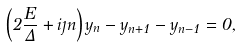<formula> <loc_0><loc_0><loc_500><loc_500>\left ( 2 \frac { E } { \Delta } + i \eta n \right ) y _ { n } - y _ { n + 1 } - y _ { n - 1 } = 0 ,</formula> 